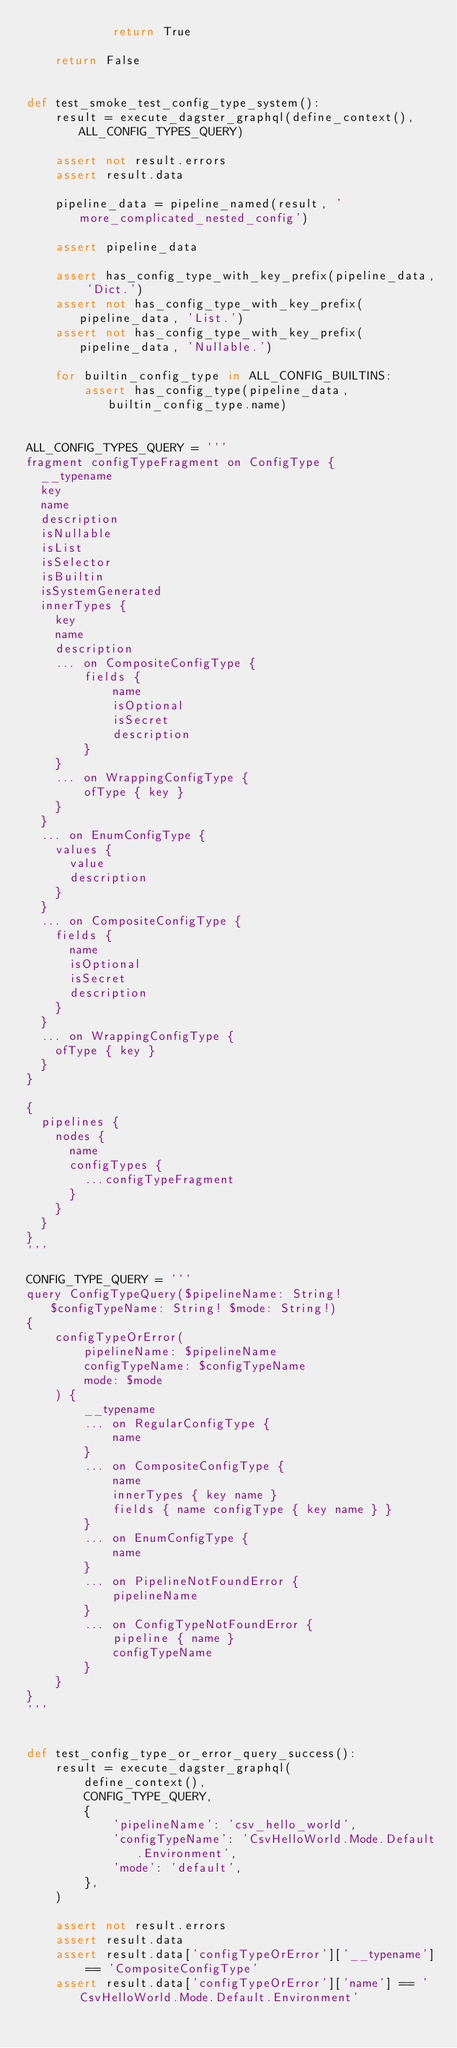Convert code to text. <code><loc_0><loc_0><loc_500><loc_500><_Python_>            return True

    return False


def test_smoke_test_config_type_system():
    result = execute_dagster_graphql(define_context(), ALL_CONFIG_TYPES_QUERY)

    assert not result.errors
    assert result.data

    pipeline_data = pipeline_named(result, 'more_complicated_nested_config')

    assert pipeline_data

    assert has_config_type_with_key_prefix(pipeline_data, 'Dict.')
    assert not has_config_type_with_key_prefix(pipeline_data, 'List.')
    assert not has_config_type_with_key_prefix(pipeline_data, 'Nullable.')

    for builtin_config_type in ALL_CONFIG_BUILTINS:
        assert has_config_type(pipeline_data, builtin_config_type.name)


ALL_CONFIG_TYPES_QUERY = '''
fragment configTypeFragment on ConfigType {
  __typename
  key
  name
  description
  isNullable
  isList
  isSelector
  isBuiltin
  isSystemGenerated
  innerTypes {
    key
    name
    description
    ... on CompositeConfigType {
        fields {
            name
            isOptional
            isSecret
            description
        }
    }
    ... on WrappingConfigType {
        ofType { key }
    }
  }
  ... on EnumConfigType {
    values {
      value
      description
    }
  }
  ... on CompositeConfigType {
    fields {
      name
      isOptional
      isSecret
      description
    }
  }
  ... on WrappingConfigType {
    ofType { key }
  }
}

{
 	pipelines {
    nodes {
      name
      configTypes {
        ...configTypeFragment
      }
    }
  } 
}
'''

CONFIG_TYPE_QUERY = '''
query ConfigTypeQuery($pipelineName: String! $configTypeName: String! $mode: String!)
{
    configTypeOrError(
        pipelineName: $pipelineName
        configTypeName: $configTypeName
        mode: $mode
    ) {
        __typename
        ... on RegularConfigType {
            name
        }
        ... on CompositeConfigType {
            name
            innerTypes { key name }
            fields { name configType { key name } }
        }
        ... on EnumConfigType {
            name
        }
        ... on PipelineNotFoundError {
            pipelineName
        }
        ... on ConfigTypeNotFoundError {
            pipeline { name }
            configTypeName
        }
    }
}
'''


def test_config_type_or_error_query_success():
    result = execute_dagster_graphql(
        define_context(),
        CONFIG_TYPE_QUERY,
        {
            'pipelineName': 'csv_hello_world',
            'configTypeName': 'CsvHelloWorld.Mode.Default.Environment',
            'mode': 'default',
        },
    )

    assert not result.errors
    assert result.data
    assert result.data['configTypeOrError']['__typename'] == 'CompositeConfigType'
    assert result.data['configTypeOrError']['name'] == 'CsvHelloWorld.Mode.Default.Environment'

</code> 